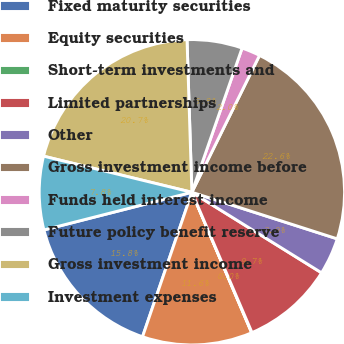Convert chart to OTSL. <chart><loc_0><loc_0><loc_500><loc_500><pie_chart><fcel>Fixed maturity securities<fcel>Equity securities<fcel>Short-term investments and<fcel>Limited partnerships<fcel>Other<fcel>Gross investment income before<fcel>Funds held interest income<fcel>Future policy benefit reserve<fcel>Gross investment income<fcel>Investment expenses<nl><fcel>15.79%<fcel>11.64%<fcel>0.04%<fcel>9.71%<fcel>3.91%<fcel>22.63%<fcel>1.97%<fcel>5.84%<fcel>20.69%<fcel>7.77%<nl></chart> 